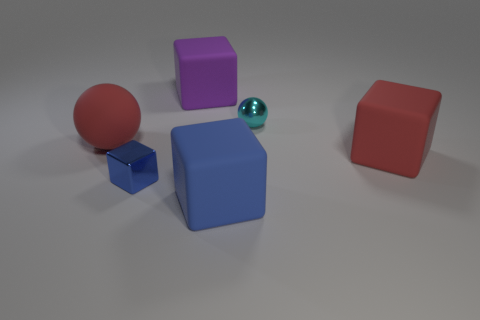Add 3 blue matte things. How many objects exist? 9 Subtract all big rubber blocks. How many blocks are left? 1 Subtract all gray spheres. How many blue blocks are left? 2 Subtract all red blocks. How many blocks are left? 3 Subtract all cubes. How many objects are left? 2 Add 1 large red blocks. How many large red blocks exist? 2 Subtract 0 green spheres. How many objects are left? 6 Subtract all red blocks. Subtract all blue cylinders. How many blocks are left? 3 Subtract all purple blocks. Subtract all tiny blue objects. How many objects are left? 4 Add 4 small cyan shiny things. How many small cyan shiny things are left? 5 